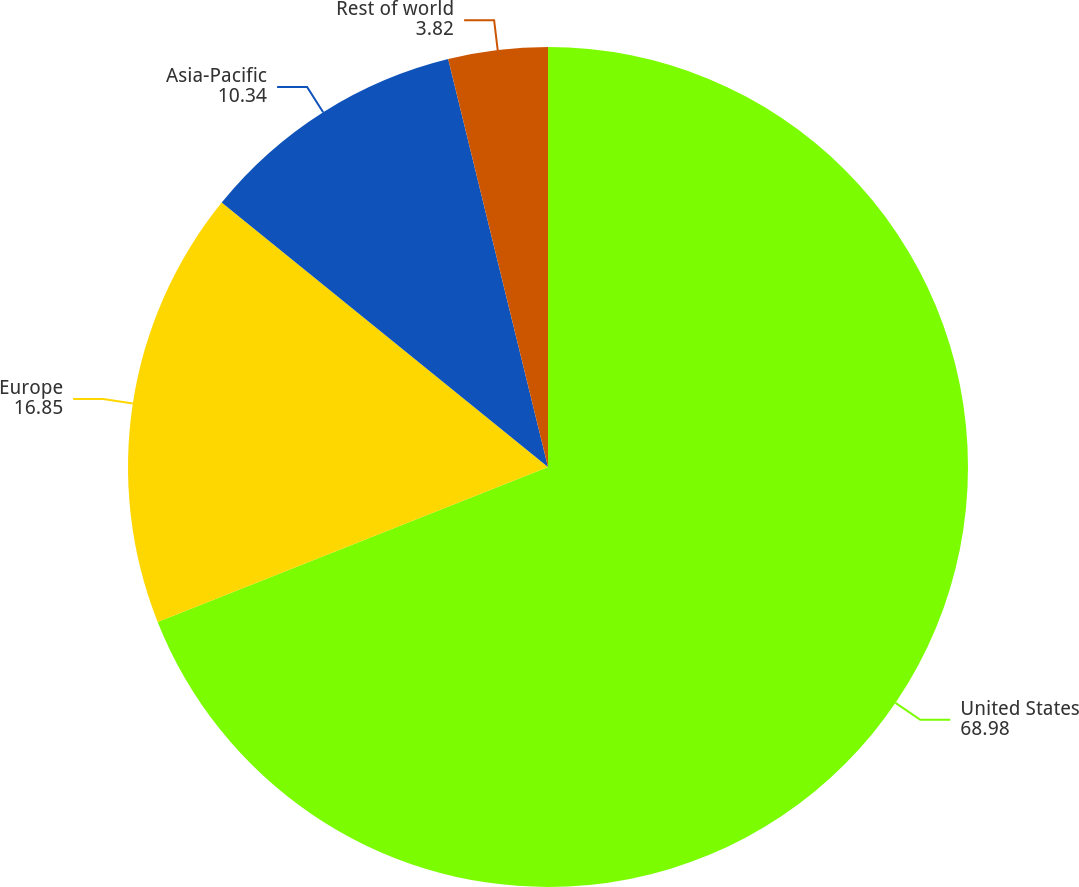Convert chart. <chart><loc_0><loc_0><loc_500><loc_500><pie_chart><fcel>United States<fcel>Europe<fcel>Asia-Pacific<fcel>Rest of world<nl><fcel>68.98%<fcel>16.85%<fcel>10.34%<fcel>3.82%<nl></chart> 